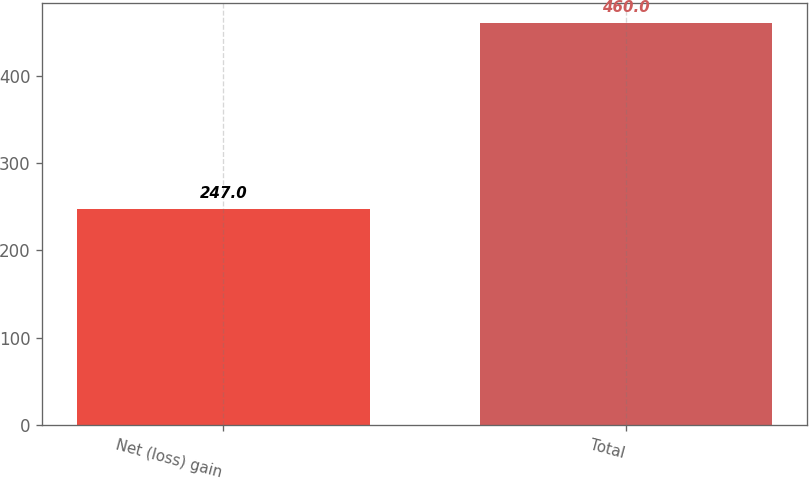Convert chart to OTSL. <chart><loc_0><loc_0><loc_500><loc_500><bar_chart><fcel>Net (loss) gain<fcel>Total<nl><fcel>247<fcel>460<nl></chart> 